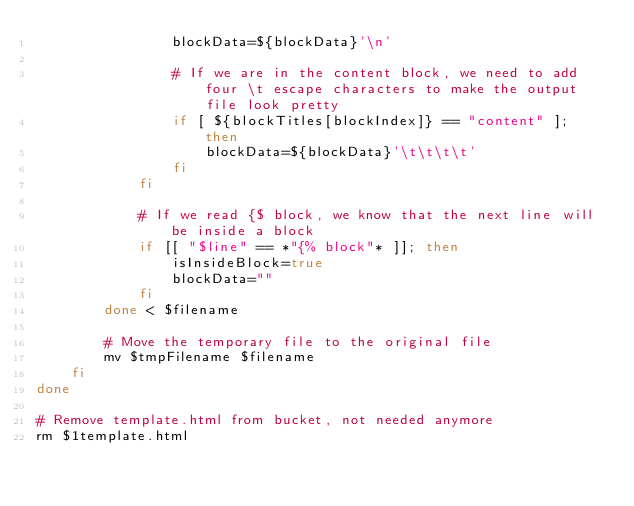Convert code to text. <code><loc_0><loc_0><loc_500><loc_500><_Bash_>				blockData=${blockData}'\n'
				
				# If we are in the content block, we need to add four \t escape characters to make the output file look pretty
				if [ ${blockTitles[blockIndex]} == "content" ]; then
					blockData=${blockData}'\t\t\t\t'
				fi
			fi

			# If we read {$ block, we know that the next line will be inside a block
			if [[ "$line" == *"{% block"* ]]; then
				isInsideBlock=true
				blockData=""
			fi
		done < $filename

		# Move the temporary file to the original file
		mv $tmpFilename $filename
	fi
done

# Remove template.html from bucket, not needed anymore
rm $1template.html</code> 